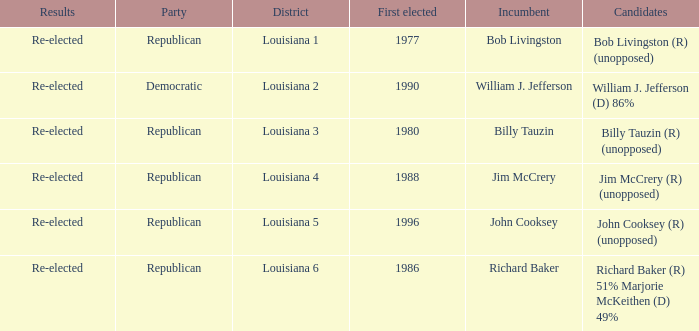How many candidates were elected first in 1980? 1.0. 